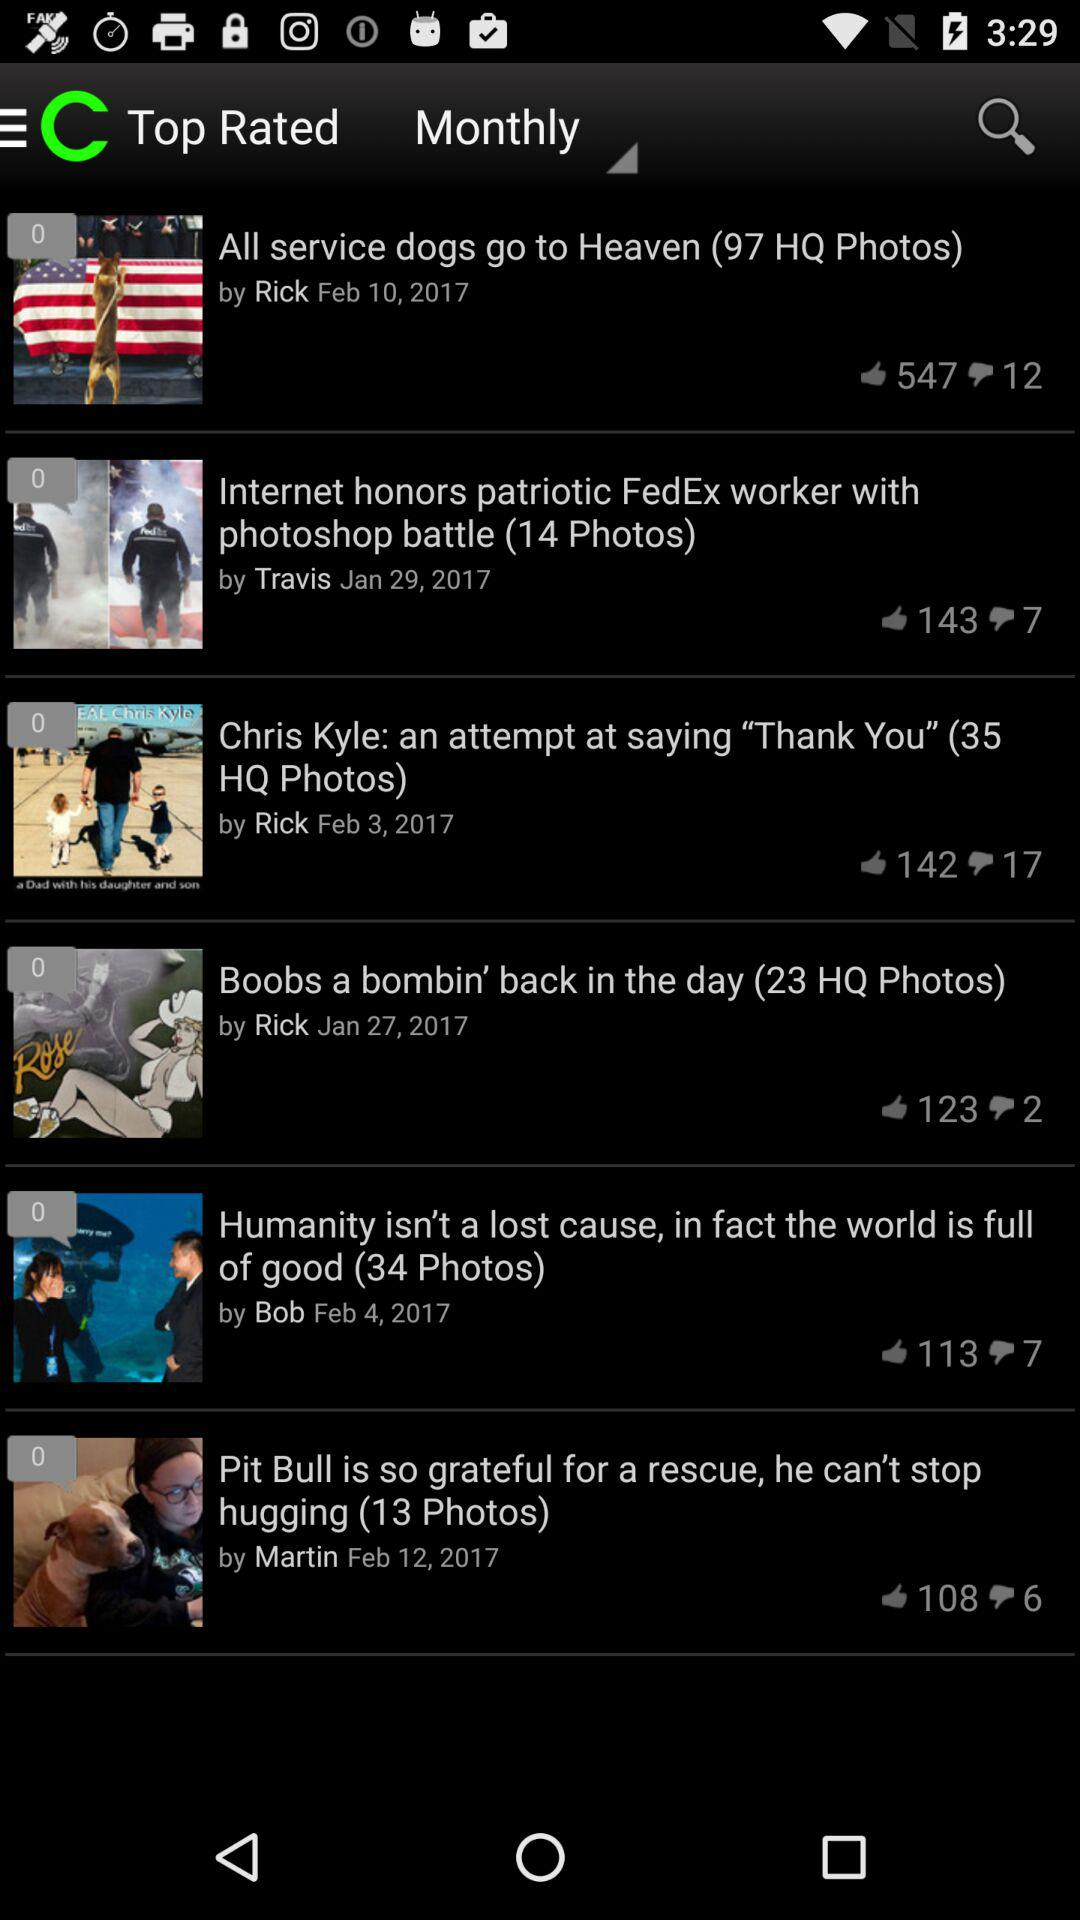Which article was posted by Martin? The article was "Pit Bull is so grateful for a rescue, he can't stop hugging (13 Photos)". 